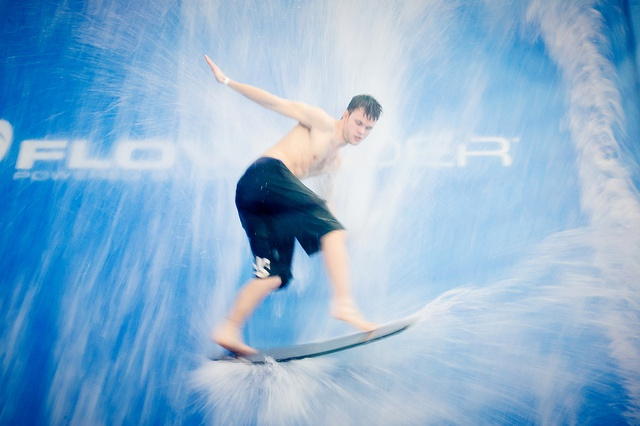Describe the objects in this image and their specific colors. I can see people in blue, lightgray, navy, and tan tones and surfboard in blue, darkgray, gray, and lightgray tones in this image. 